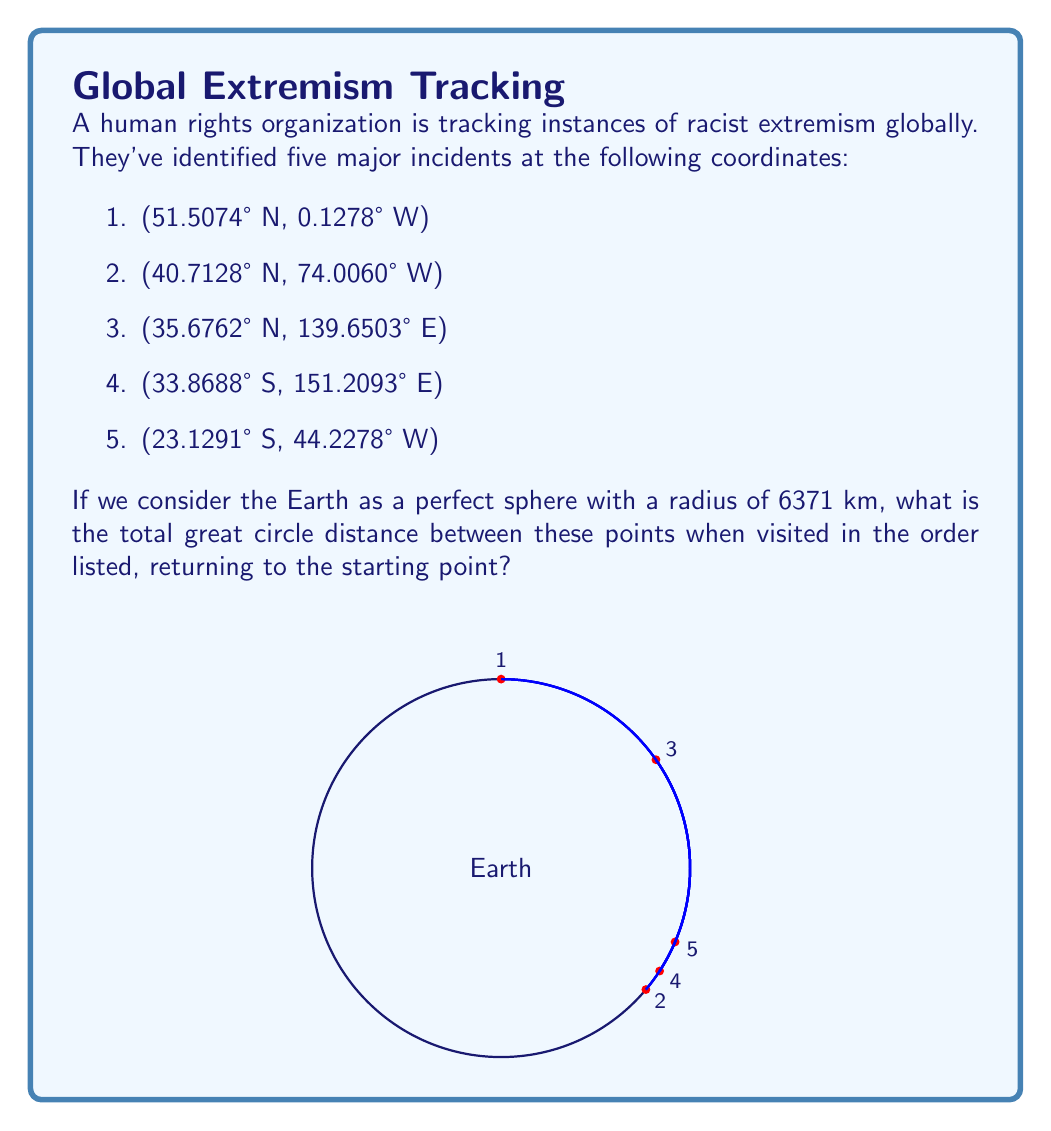Provide a solution to this math problem. To solve this problem, we need to:
1. Convert the given coordinates to radians
2. Calculate the great circle distance between each pair of consecutive points
3. Sum up all the distances

Step 1: Convert coordinates to radians
For each point $(lat, lon)$, we convert to radians:
$lat_{rad} = lat \times \frac{\pi}{180}$
$lon_{rad} = lon \times \frac{\pi}{180}$

Step 2: Calculate great circle distances
For each pair of points $(lat1, lon1)$ and $(lat2, lon2)$, we use the Haversine formula:

$$ a = \sin^2(\frac{\Delta lat}{2}) + \cos(lat1) \times \cos(lat2) \times \sin^2(\frac{\Delta lon}{2}) $$
$$ c = 2 \times \text{atan2}(\sqrt{a}, \sqrt{1-a}) $$
$$ d = R \times c $$

Where $R$ is the Earth's radius (6371 km), and $d$ is the distance.

Step 3: Sum up the distances
We calculate the distance between:
1-2, 2-3, 3-4, 4-5, 5-1

Using a calculator or computer program to perform these calculations, we get:

1-2: 5570 km
2-3: 10,880 km
3-4: 7820 km
4-5: 13,330 km
5-1: 9650 km

Total distance: 5570 + 10880 + 7820 + 13330 + 9650 = 47,250 km
Answer: 47,250 km 